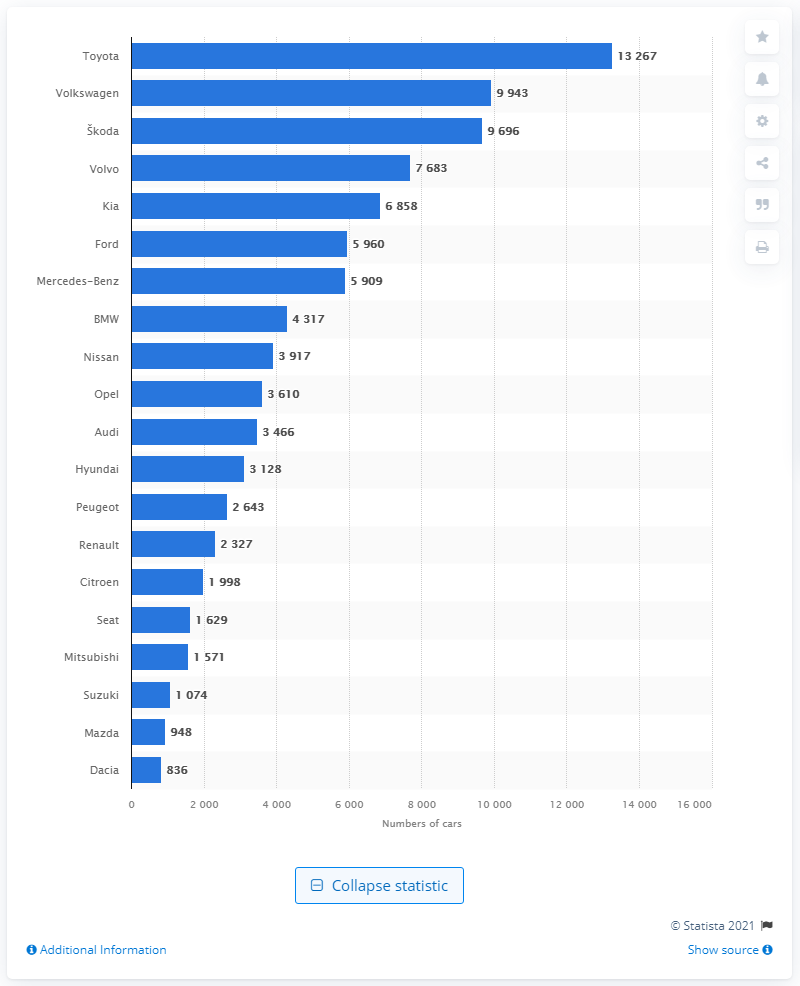Identify some key points in this picture. According to the data released by the National Highway Traffic Safety Administration in 2020, Toyota was the leading passenger car brand in Finland. In 2020, Toyota sold a total of 13,267 passenger cars in Finland. In 2020, Volkswagen sold a total of 9,943 passenger cars in Finland. 